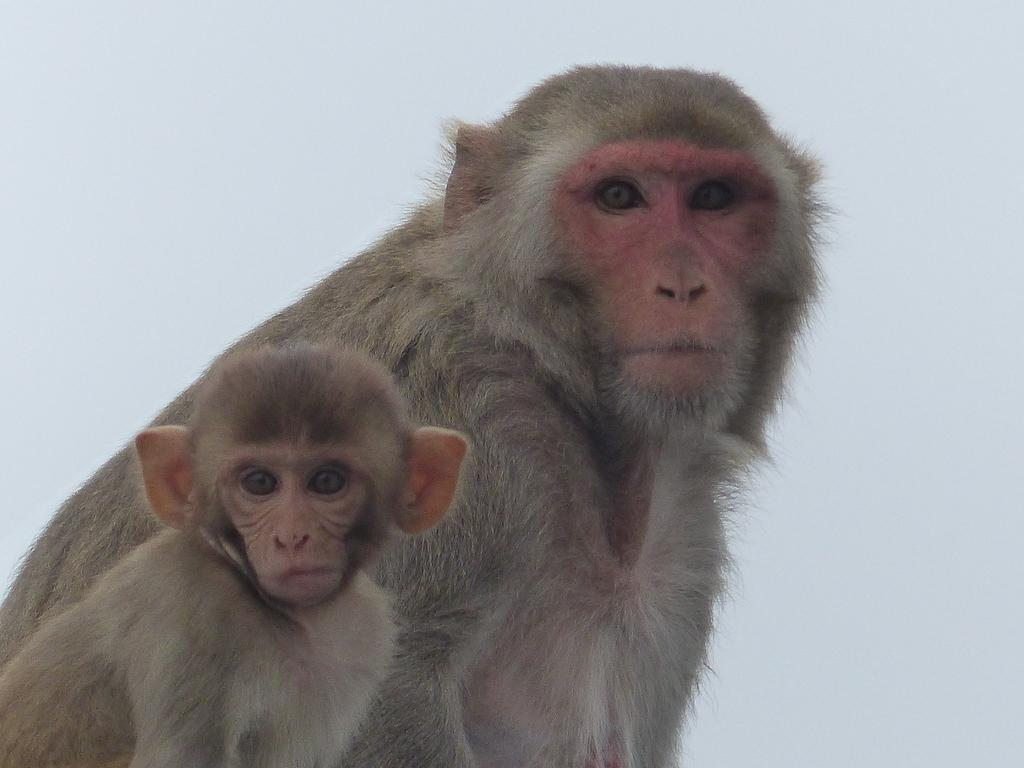What type of animals are in the image? There is a big monkey and a baby monkey in the image. What are the monkeys doing in the image? The monkeys are sitting in the image. Are the monkeys looking at something or someone? Yes, the monkeys are looking at someone in the image. What type of jeans is the baby monkey wearing in the image? There are no jeans present in the image, as monkeys do not wear clothing. 